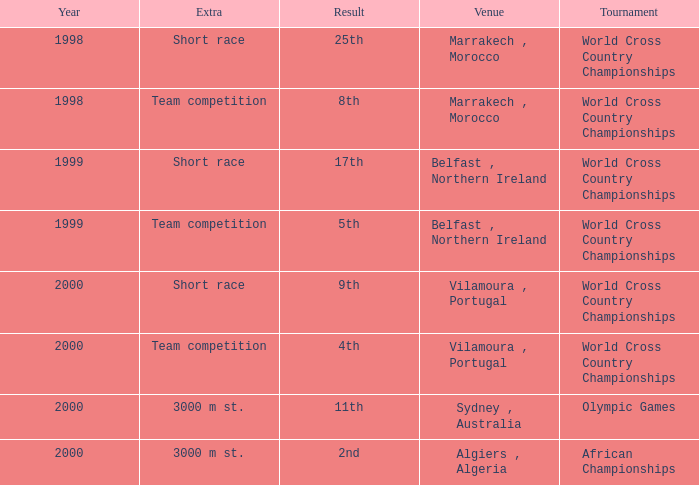Tell me the sum of year for 5th result 1999.0. 